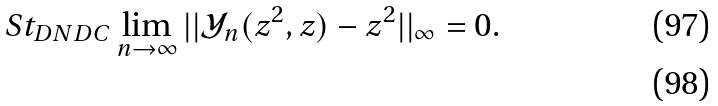Convert formula to latex. <formula><loc_0><loc_0><loc_500><loc_500>S t _ { D N D C } \lim _ { n \rightarrow \infty } | | \mathcal { Y } _ { n } ( z ^ { 2 } , z ) - z ^ { 2 } | | _ { \infty } = 0 . \\</formula> 